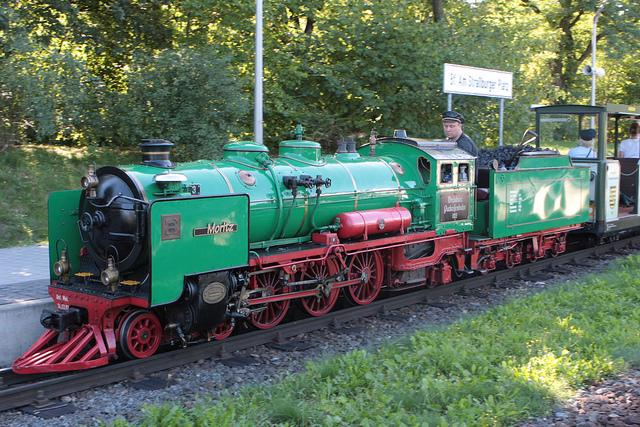What is the man doing at the front of the train car? Please explain your reasoning. driving. A man in a uniform is standing at the beginning of a train. a conductor drives the train. 